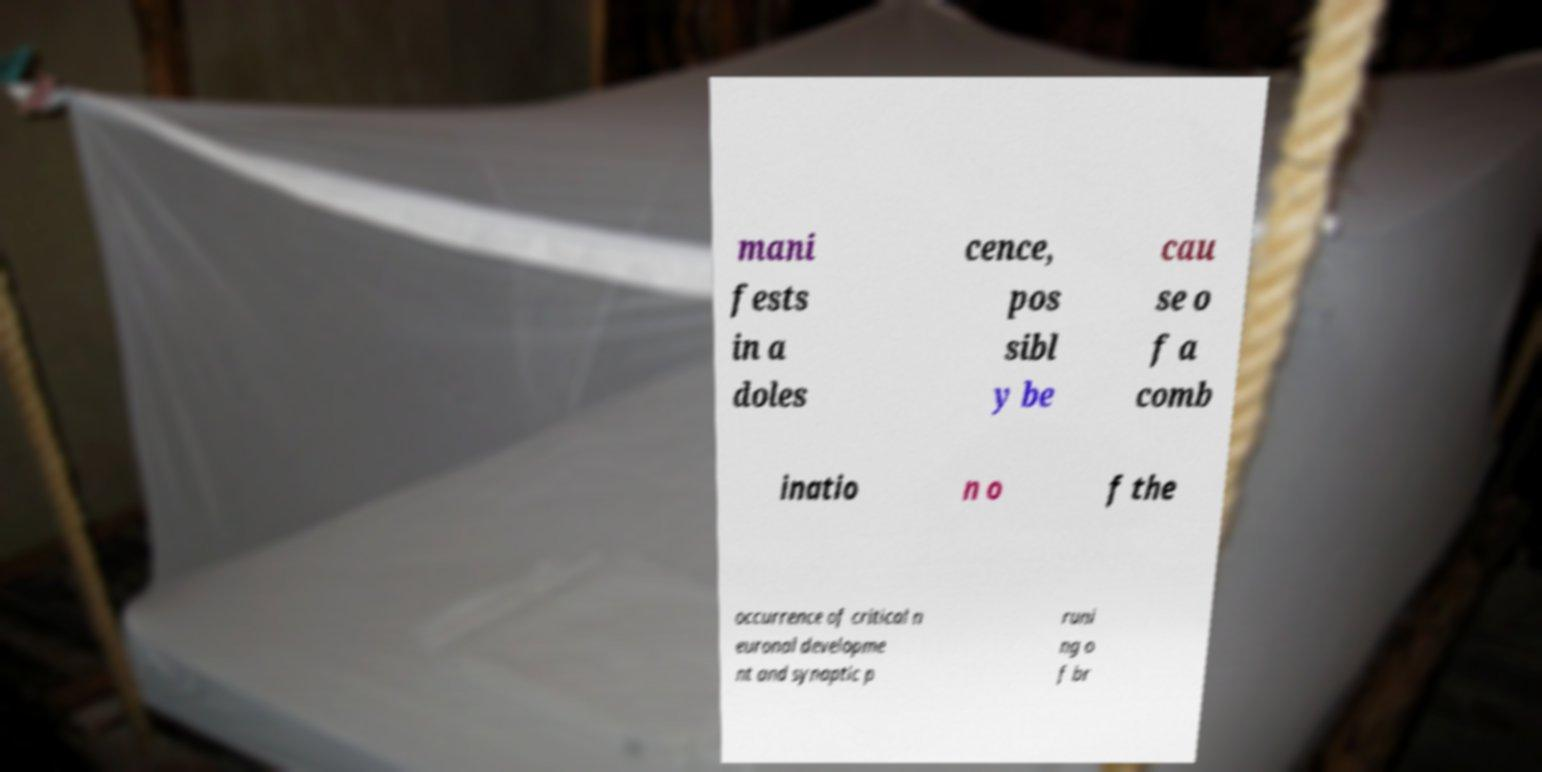Could you assist in decoding the text presented in this image and type it out clearly? mani fests in a doles cence, pos sibl y be cau se o f a comb inatio n o f the occurrence of critical n euronal developme nt and synaptic p runi ng o f br 